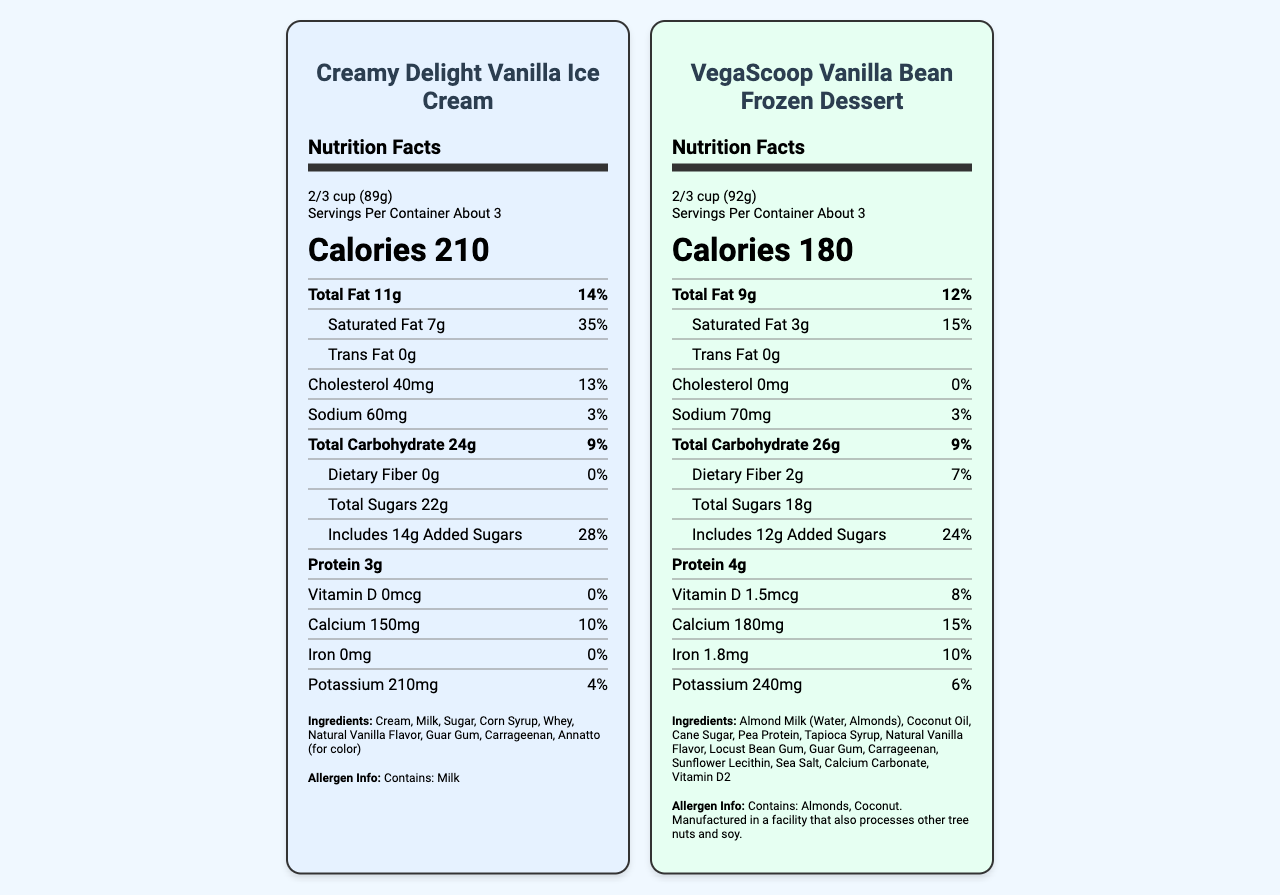what is the serving size of VegaScoop Vanilla Bean Frozen Dessert? The serving size is mentioned at the top of the nutrition label under the product name "VegaScoop Vanilla Bean Frozen Dessert".
Answer: 2/3 cup (92g) how many calories are in a serving of Creamy Delight Vanilla Ice Cream? The number of calories is prominently displayed in large text under the serving information for "Creamy Delight Vanilla Ice Cream".
Answer: 210 what is the total fat content for both products? The total fat content can be found under the "Total Fat" section for each product.
Answer: Creamy Delight Vanilla Ice Cream: 11g, VegaScoop Vanilla Bean Frozen Dessert: 9g which product has more protein? VegaScoop has 4g of protein, while Creamy Delight has 3g.
Answer: VegaScoop Vanilla Bean Frozen Dessert what is the sugar content difference between the two products? Creamy Delight Vanilla Ice Cream has 22g of total sugars whereas VegaScoop Vanilla Bean Frozen Dessert has 18g. The difference is 22g - 18g = 4g.
Answer: 4g which product has a higher percentage of daily value for calcium? A. Creamy Delight Vanilla Ice Cream B. VegaScoop Vanilla Bean Frozen Dessert Creamy Delight has 10% daily value for calcium, while VegaScoop has 15%. Therefore, VegaScoop has a higher percentage.
Answer: B how many grams of dietary fiber are in VegaScoop Vanilla Bean Frozen Dessert? The dietary fiber content is listed under the "Total Carbohydrate" section for VegaScoop Vanilla Bean Frozen Dessert.
Answer: 2g does Creamy Delight Vanilla Ice Cream contain any iron? Creamy Delight Vanilla Ice Cream has 0mg of iron as listed on its nutrition label.
Answer: No compare the cholesterol content in both products. Which one contains cholesterol? A. Creamy Delight Vanilla Ice Cream B. VegaScoop Vanilla Bean Frozen Dessert C. Both D. Neither Creamy Delight Vanilla Ice Cream contains 40mg of cholesterol, while VegaScoop Vanilla Bean Frozen Dessert contains 0mg.
Answer: A does VegaScoop Vanilla Bean Frozen Dessert have any allergens? VegaScoop Vanilla Bean Frozen Dessert contains almonds and coconut as noted in the allergen information.
Answer: Yes how would you summarize the main differences between the two nutrition labels? The summary captures the key differences in nutritional content between the two products, noting higher values for unhealthy components in the dairy option and higher values for beneficial nutrients in the plant-based option.
Answer: Creamy Delight Vanilla Ice Cream is higher in calories, total fat, saturated fat, cholesterol, and sugars compared to VegaScoop Vanilla Bean Frozen Dessert. VegaScoop, however, contains higher protein, dietary fiber, calcium, iron, and potassium, and includes some added vitamins like Vitamin D. which product is higher in saturated fats? Creamy Delight Vanilla Ice Cream has 7g of saturated fat, whereas VegaScoop Vanilla Bean Frozen Dessert has only 3g.
Answer: Creamy Delight Vanilla Ice Cream are there any ingredients common in both products? A. Yes B No Both products contain sugar, natural vanilla flavor, guar gum, and carrageenan.
Answer: A which one has more sodium? VegaScoop has 70mg of sodium whereas Creamy Delight has 60mg.
Answer: VegaScoop Vanilla Bean Frozen Dessert what is the daily value percentage for carbohydrates in both products? The % daily value for carbohydrates is listed as 9% for both products under the "Total Carbohydrate" section.
Answer: Both products have 9% daily value for total carbohydrates what are the main ingredients of VegaScoop Vanilla Bean Frozen Dessert? The ingredients are listed at the bottom of VegaScoop Vanilla Bean Frozen Dessert's nutrition label.
Answer: Almond Milk (Water, Almonds), Coconut Oil, Cane Sugar, Pea Protein, Tapioca Syrup, Natural Vanilla Flavor, Locust Bean Gum, Guar Gum, Carrageenan, Sunflower Lecithin, Sea Salt, Calcium Carbonate, Vitamin D2 can you determine the price of either product from the nutrition facts labels? The document does not contain any pricing information. The focus of the nutrition facts labels is solely on the nutritional content and ingredients.
Answer: Not enough information 